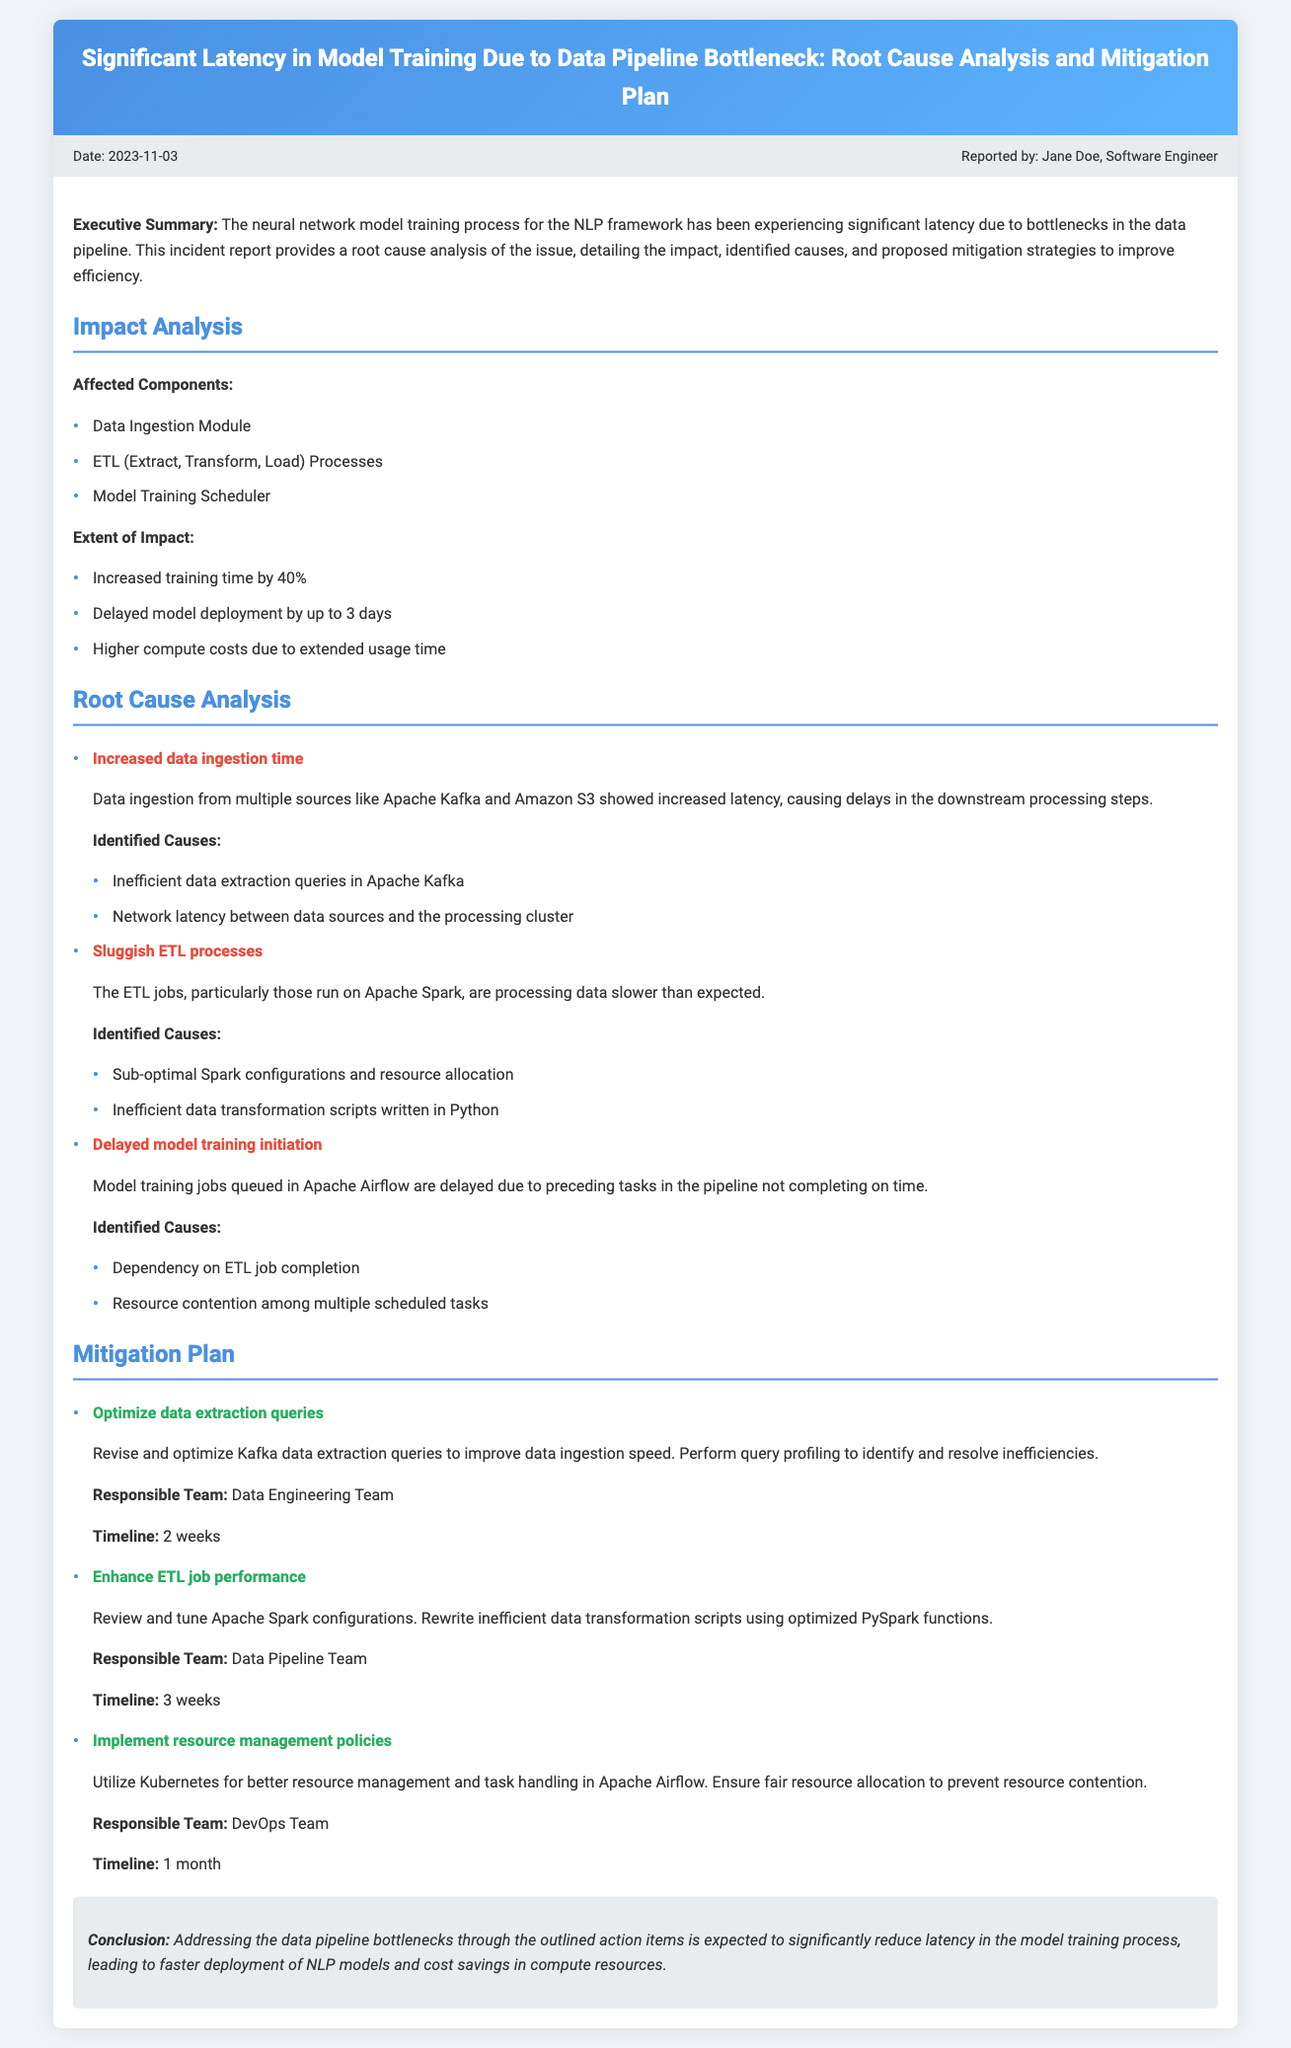What is the date of the incident report? The report is dated November 3, 2023, as stated in the meta section.
Answer: November 3, 2023 Who reported the incident? The incident report indicates that Jane Doe, a Software Engineer, reported the incident.
Answer: Jane Doe What is the percentage increase in training time? The report mentions that the training time has increased by 40%.
Answer: 40% Which module showed increased data ingestion time? The affected module specifically mentioned is the Data Ingestion Module.
Answer: Data Ingestion Module What is the primary identified cause of sluggish ETL processes? Sub-optimal Spark configurations and resource allocation are highlighted as a primary cause.
Answer: Sub-optimal Spark configurations How long is the timeline for optimizing data extraction queries? The report states that the timeline for this action item is 2 weeks.
Answer: 2 weeks What is the responsible team for enhancing ETL job performance? The document specifies that the Data Pipeline Team is responsible for this mitigation.
Answer: Data Pipeline Team What impact did the bottleneck have on model deployment? The report notes that the latency caused delays in model deployment by up to 3 days.
Answer: Up to 3 days What action is planned to implement resource management policies? The document indicates that utilizing Kubernetes is planned for better resource management.
Answer: Utilizing Kubernetes 